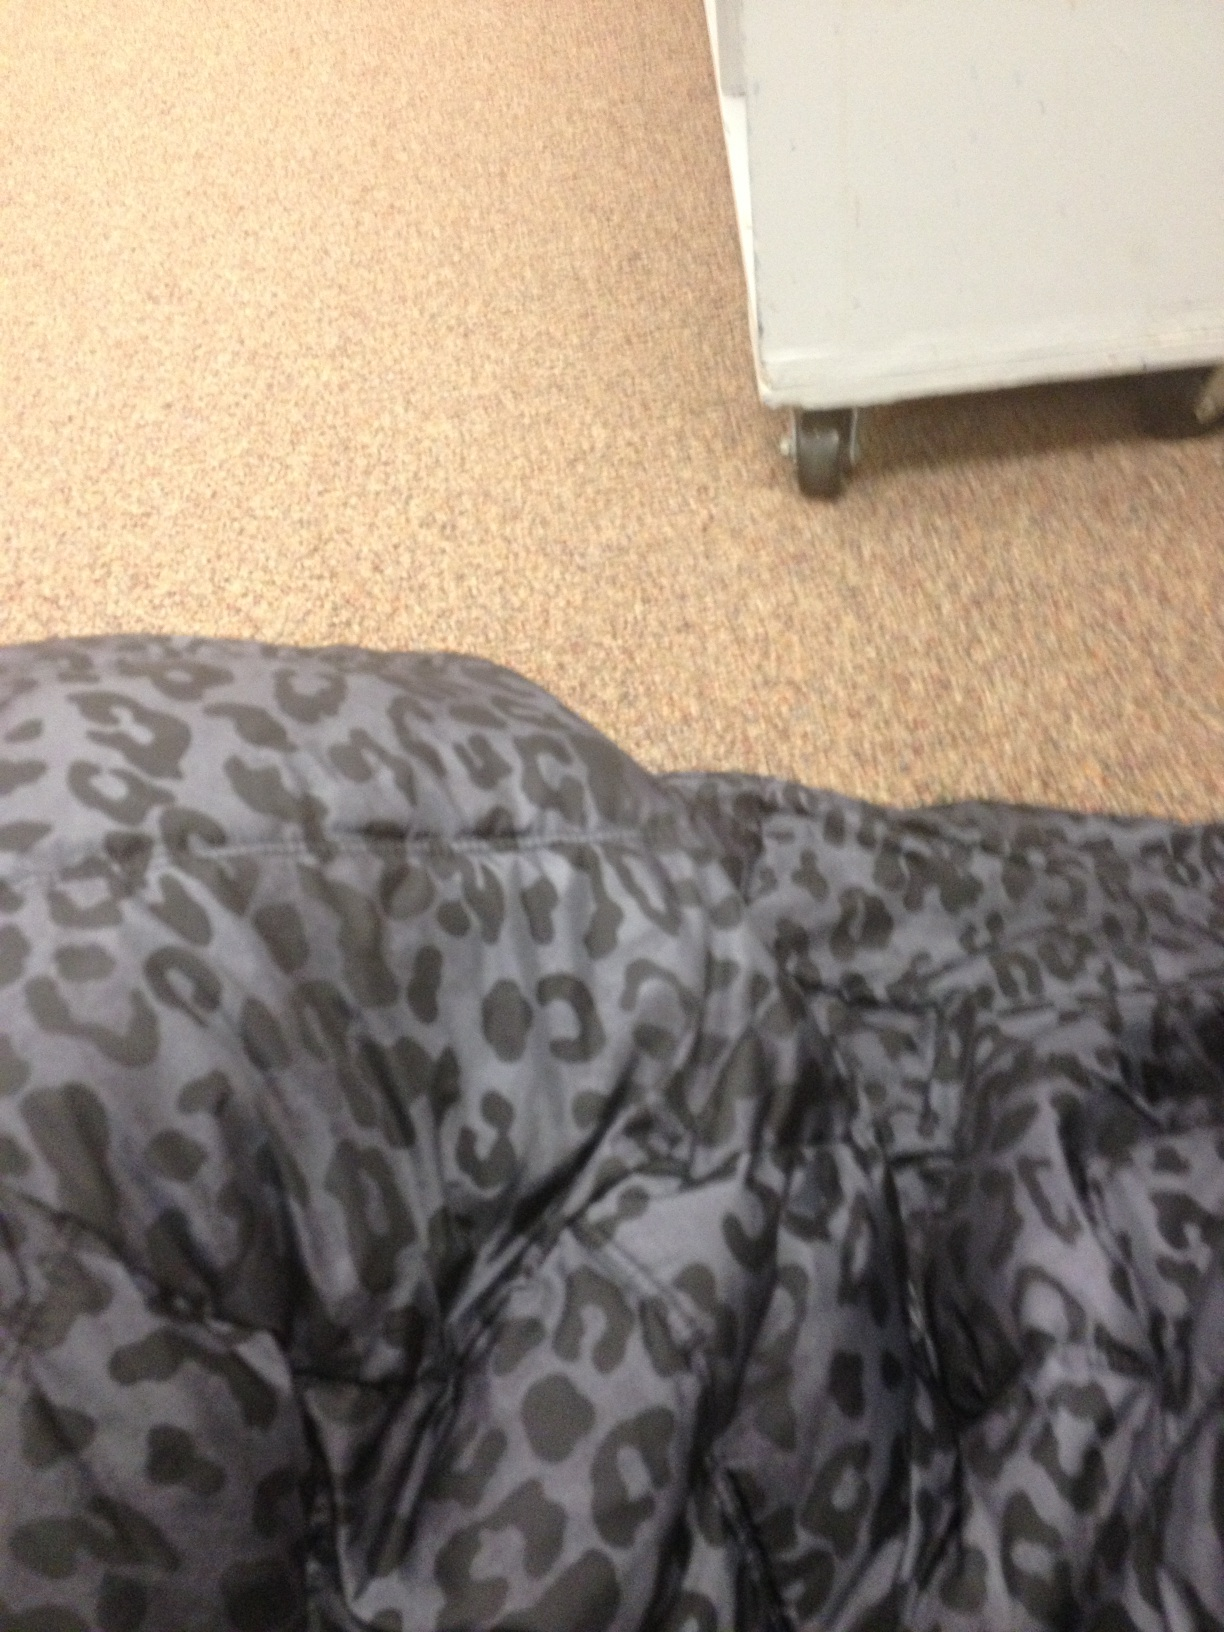What could be the use of this patterned fabric? Cheetah print is often used in fashion for creating bold statements. It's likely that this fabric is part of a clothing item such as a jacket, pants, or accessory that aims to make an impactful and stylish impression. 